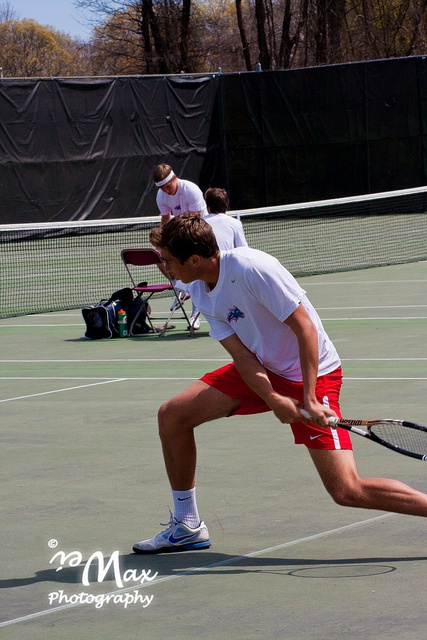Describe the objects in this image and their specific colors. I can see people in lightblue, maroon, black, gray, and lavender tones, people in lightblue, gray, lavender, black, and maroon tones, chair in lightblue, black, darkgray, and gray tones, tennis racket in lightblue, gray, and black tones, and people in lightblue, lavender, black, darkgray, and maroon tones in this image. 